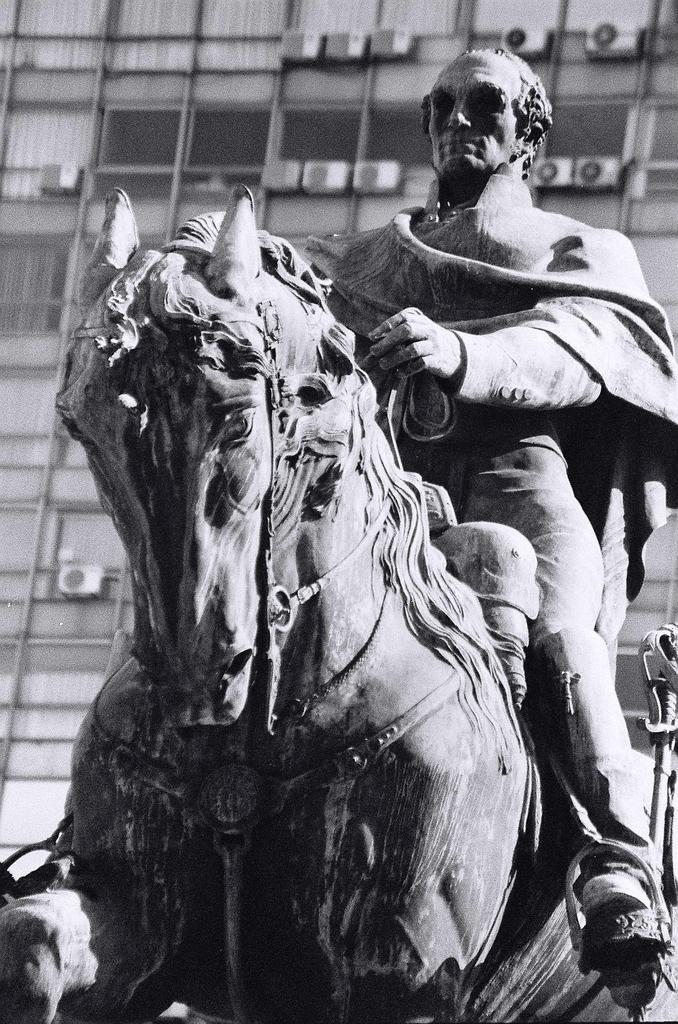How would you summarize this image in a sentence or two? In this picture there is man who is sitting on the horse this is a statue, there is a building behind the man 